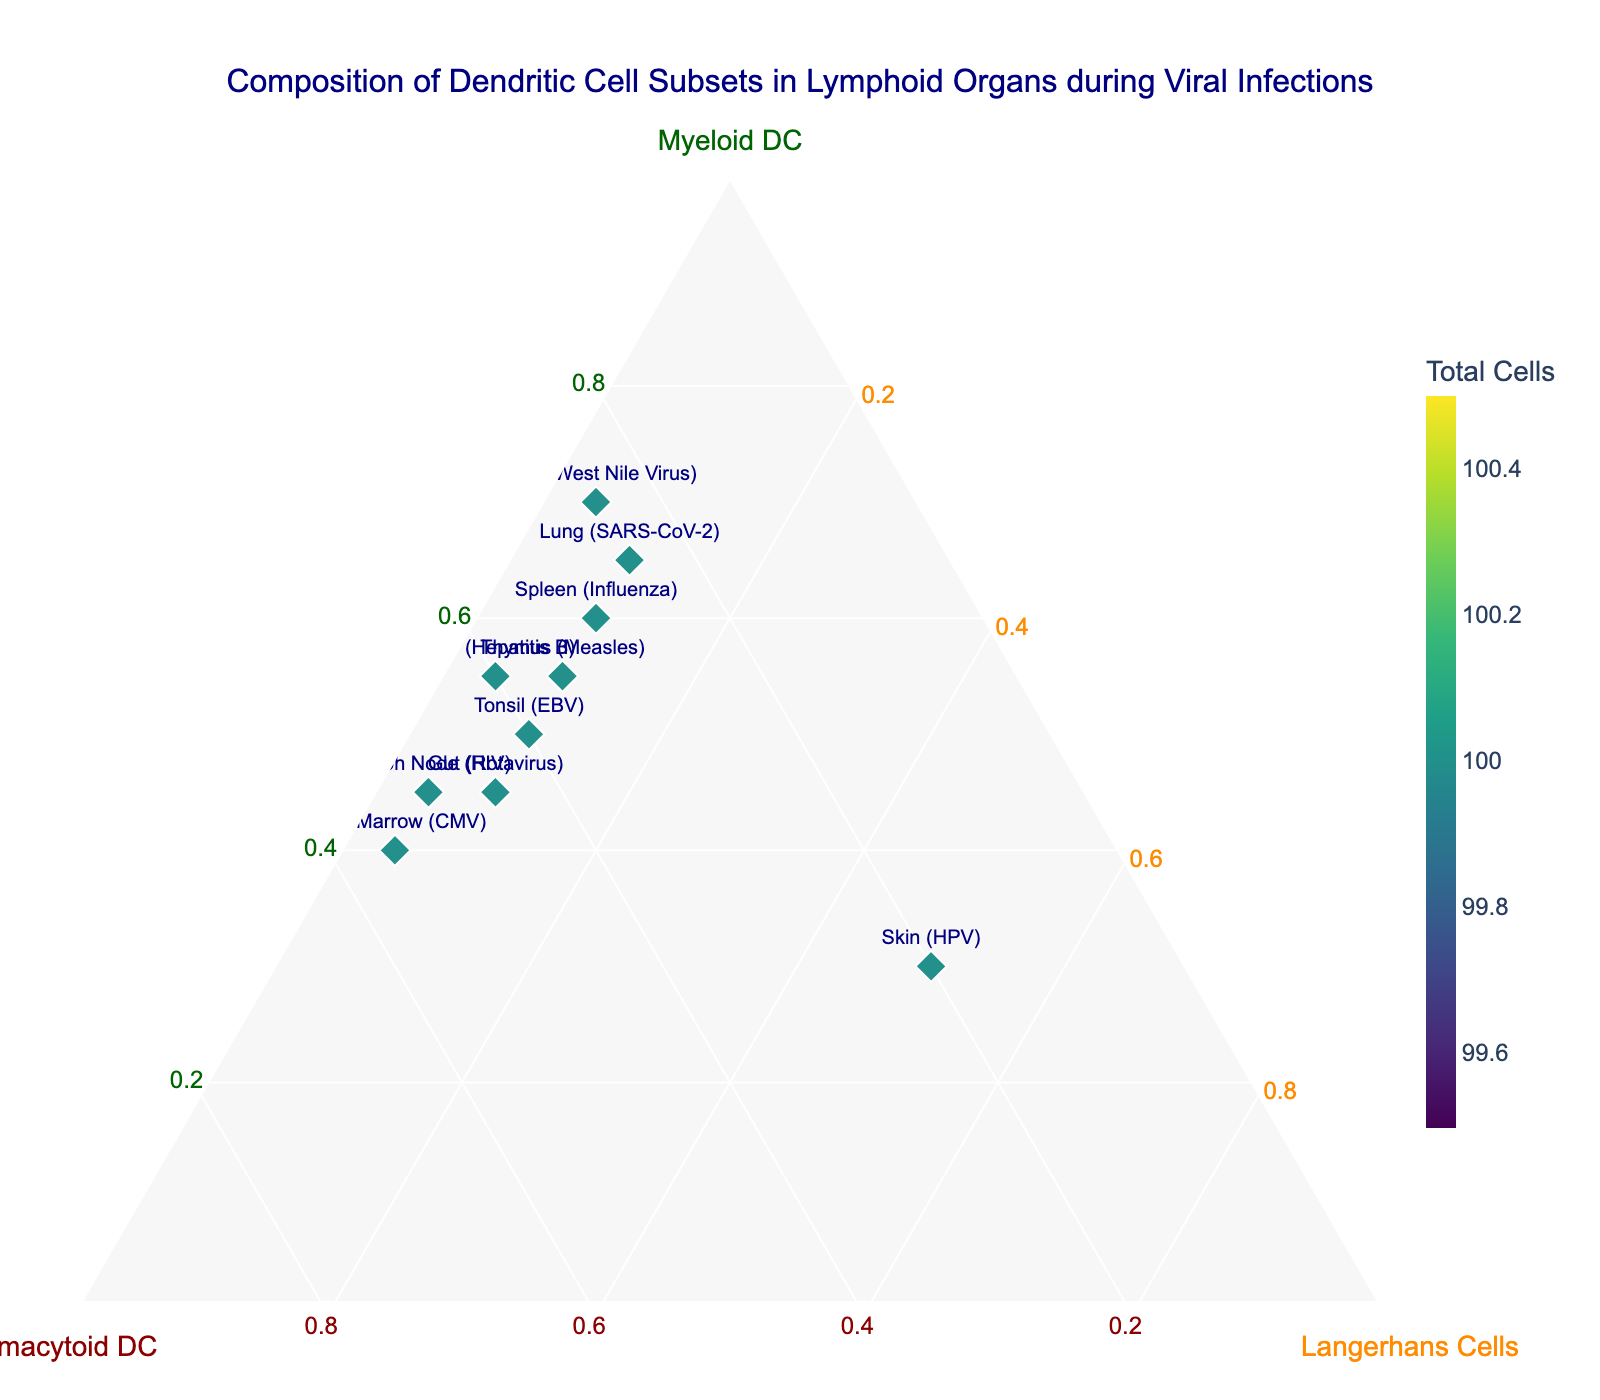Which sample has the highest percentage of Myeloid DC? By observing the ternary plot, we can find the sample with the highest value along the Myeloid DC axis. The Liver (Hepatitis B) sample has the highest percentage of Myeloid DC at 70%.
Answer: Brain (West Nile Virus) How many samples contain a higher percentage of Plasmacytoid DC than Myeloid DC? To answer, we compare each sample's percentage of Plasmacytoid DC and Myeloid DC. The samples are Bone Marrow (CMV) and Lymph Node (HIV), both having a higher percentage of Plasmacytoid DC than Myeloid DC.
Answer: 2 Which samples share the same percentage of Langerhans Cells? By examining the percentages on the Langerhans Cells axis, we find that Spleen (Influenza), Thymus (Measles), Tonsil (EBV), Lung (SARS-CoV-2), and Gut (Rotavirus) all have 10%.
Answer: Spleen (Influenza), Thymus (Measles), Tonsil (EBV), Lung (SARS-CoV-2), Gut (Rotavirus) What is the average percentage of Langerhans Cells across all samples? Sum all percentages of Langerhans Cells, then divide by the number of samples: (10+5+10+10+5+50+10+5+5+10)/10 = 12%.
Answer: 12% Which sample has the highest total number of dendritic cells? By checking the color scale indicator corresponding to the total cells, the Lung (SARS-CoV-2) sample has the darkest color, indicating the highest total number.
Answer: Lung (SARS-CoV-2) Are there any samples where the percentage of Myeloid DC and Plasmacytoid DC are equal? We compare the two percentages for each sample and find that the Gut (Rotavirus) sample has both percentages at 45%.
Answer: Gut (Rotavirus) How does the composition of dendritic cells in the Skin (HPV) compare to the Brain (West Nile Virus)? For the Skin (HPV) sample: Myeloid DC (30%), Plasmacytoid DC (20%), Langerhans Cells (50%). For the Brain (West Nile Virus) sample: Myeloid DC (70%), Plasmacytoid DC (25%), Langerhans Cells (5%). The Skin sample has a higher percentage of Langerhans Cells, whereas the Brain sample has a higher percentage of Myeloid and Plasmacytoid DC.
Answer: Skin has 50% Langerhans vs 5%, Brain has 70% Myeloid vs 30% Is there any organ where Langerhans Cells make up more than 40% of the dendritic cells? Searching through the plot, only the Skin (HPV) sample shows Langerhans Cells making up 50%, which is more than 40%.
Answer: Skin (HPV) 